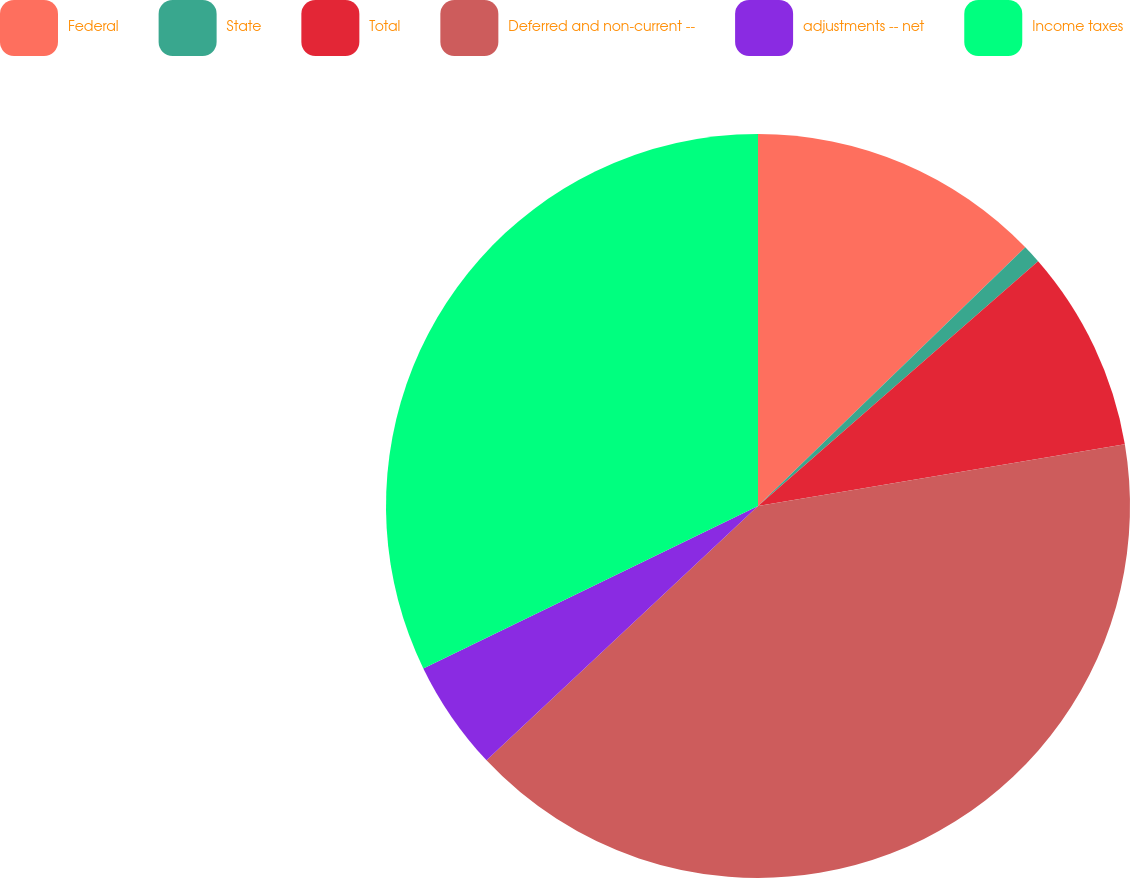Convert chart to OTSL. <chart><loc_0><loc_0><loc_500><loc_500><pie_chart><fcel>Federal<fcel>State<fcel>Total<fcel>Deferred and non-current --<fcel>adjustments -- net<fcel>Income taxes<nl><fcel>12.76%<fcel>0.81%<fcel>8.78%<fcel>40.67%<fcel>4.79%<fcel>32.19%<nl></chart> 